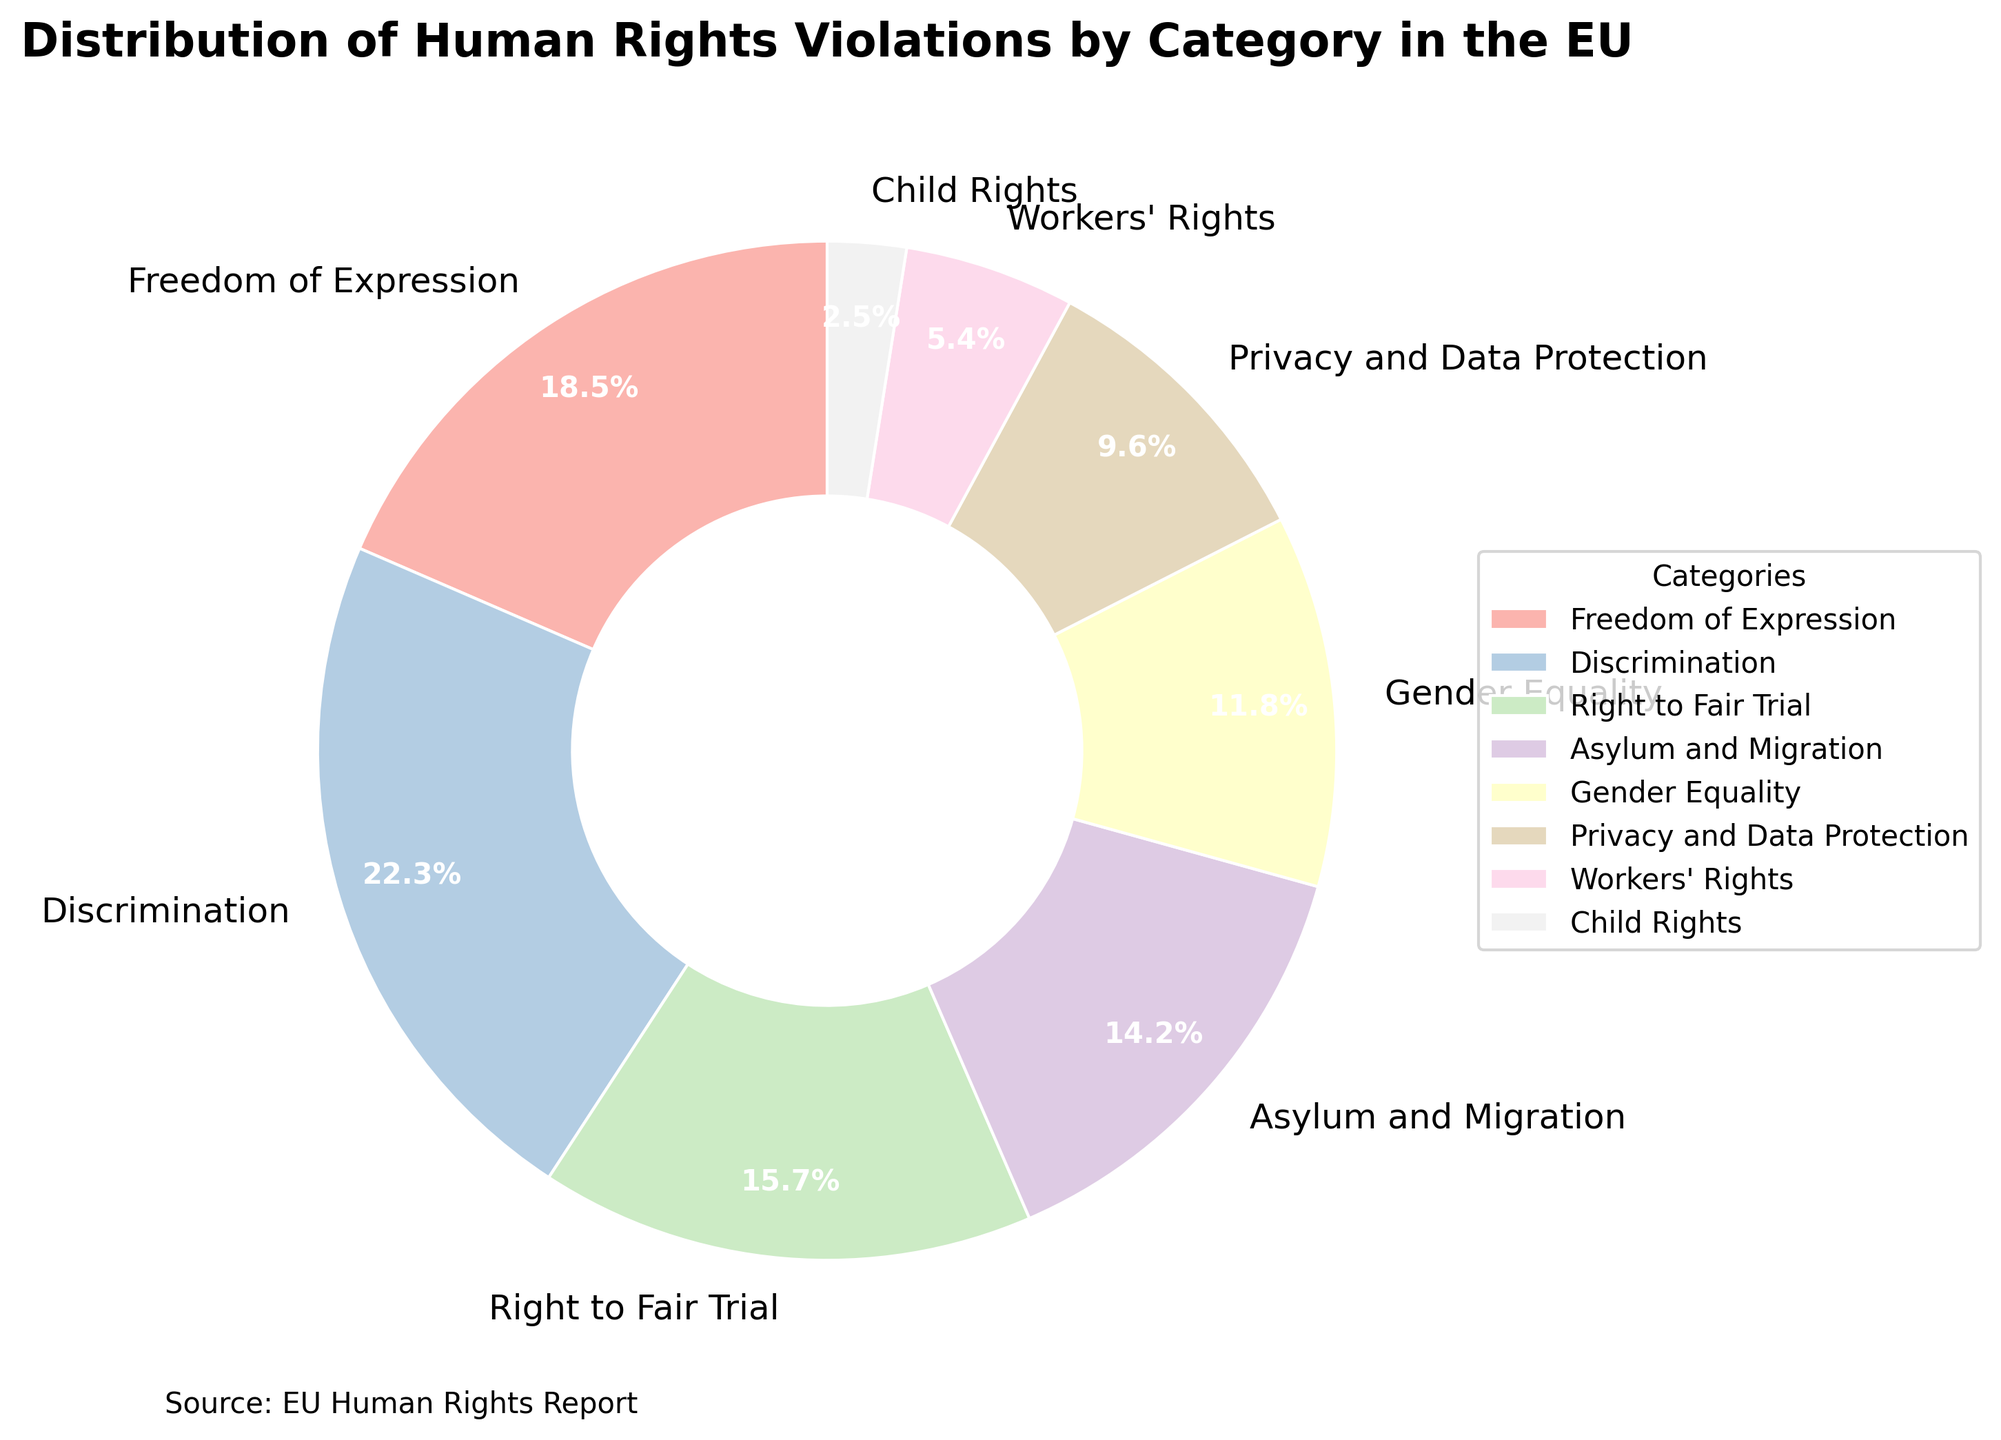Which category has the highest percentage of human rights violations? By observing the pie chart, we can see that the category with the largest slice represents the highest percentage.
Answer: Discrimination Which two categories together account for more than one third of the violations? To find the answer, we need to sum the percentages of different categories and identify those that together exceed 33.3%. From the chart, Discrimination (22.3%) and Freedom of Expression (18.5%) together account for 40.8%.
Answer: Discrimination and Freedom of Expression How much less are violations in Child Rights compared to Privacy and Data Protection? Subtract the percentage of Child Rights from Privacy and Data Protection. From the chart, Privacy and Data Protection is 9.6% and Child Rights is 2.5%. So, 9.6% - 2.5% = 7.1%.
Answer: 7.1% If Workers' Rights and Child Rights are combined, do they surpass Asylum and Migration? Add the percentages of Workers' Rights (5.4%) and Child Rights (2.5%) and compare to Asylum and Migration (14.2%). Combined, they sum to 5.4% + 2.5% = 7.9%, which is less than 14.2%.
Answer: No What is the percentage gap between the highest and lowest categories? Subtract the percentage of the lowest category, Child Rights (2.5%), from the highest category, Discrimination (22.3%). 22.3% - 2.5% = 19.8%.
Answer: 19.8% Which category has the smallest representation and what is its percentage? By looking at the pie chart, the smallest slice represents the lowest percentage. It belongs to Child Rights with 2.5%.
Answer: Child Rights, 2.5% How do Gender Equality and Workers' Rights compare in terms of their percentage of violations? Compare the slices of Gender Equality (11.8%) and Workers' Rights (5.4%). Gender Equality is larger by 11.8% - 5.4% = 6.4%.
Answer: Gender Equality is 6.4% more than Workers' Rights Calculate the total percentage of violations from Asylum and Migration, Gender Equality, and Workers' Rights combined. Add the percentages of the three categories: Asylum and Migration (14.2%), Gender Equality (11.8%), and Workers' Rights (5.4%). 14.2% + 11.8% + 5.4% = 31.4%.
Answer: 31.4% What percentage of violations are related to personal rights (combining Privacy and Data Protection and the Right to Fair Trial)? Sum the percentages of Privacy and Data Protection (9.6%) and Right to Fair Trial (15.7%). 9.6% + 15.7% = 25.3%.
Answer: 25.3% 